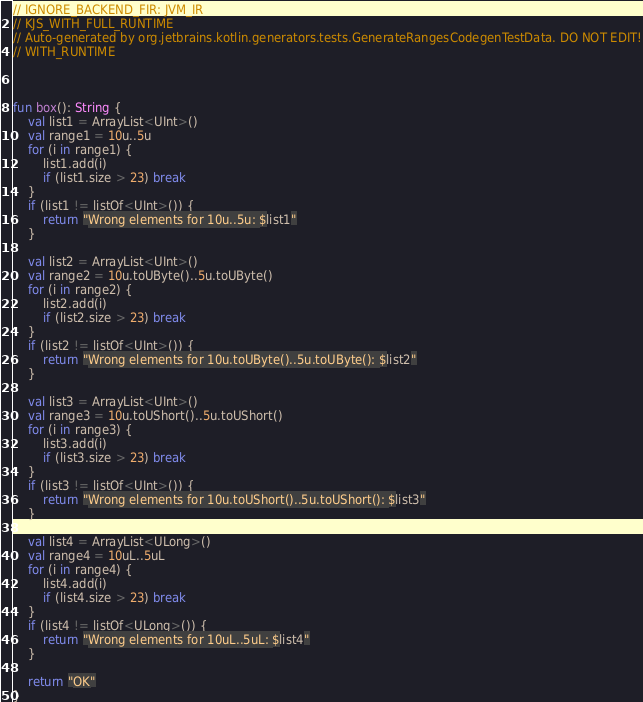Convert code to text. <code><loc_0><loc_0><loc_500><loc_500><_Kotlin_>// IGNORE_BACKEND_FIR: JVM_IR
// KJS_WITH_FULL_RUNTIME
// Auto-generated by org.jetbrains.kotlin.generators.tests.GenerateRangesCodegenTestData. DO NOT EDIT!
// WITH_RUNTIME



fun box(): String {
    val list1 = ArrayList<UInt>()
    val range1 = 10u..5u
    for (i in range1) {
        list1.add(i)
        if (list1.size > 23) break
    }
    if (list1 != listOf<UInt>()) {
        return "Wrong elements for 10u..5u: $list1"
    }

    val list2 = ArrayList<UInt>()
    val range2 = 10u.toUByte()..5u.toUByte()
    for (i in range2) {
        list2.add(i)
        if (list2.size > 23) break
    }
    if (list2 != listOf<UInt>()) {
        return "Wrong elements for 10u.toUByte()..5u.toUByte(): $list2"
    }

    val list3 = ArrayList<UInt>()
    val range3 = 10u.toUShort()..5u.toUShort()
    for (i in range3) {
        list3.add(i)
        if (list3.size > 23) break
    }
    if (list3 != listOf<UInt>()) {
        return "Wrong elements for 10u.toUShort()..5u.toUShort(): $list3"
    }

    val list4 = ArrayList<ULong>()
    val range4 = 10uL..5uL
    for (i in range4) {
        list4.add(i)
        if (list4.size > 23) break
    }
    if (list4 != listOf<ULong>()) {
        return "Wrong elements for 10uL..5uL: $list4"
    }

    return "OK"
}
</code> 